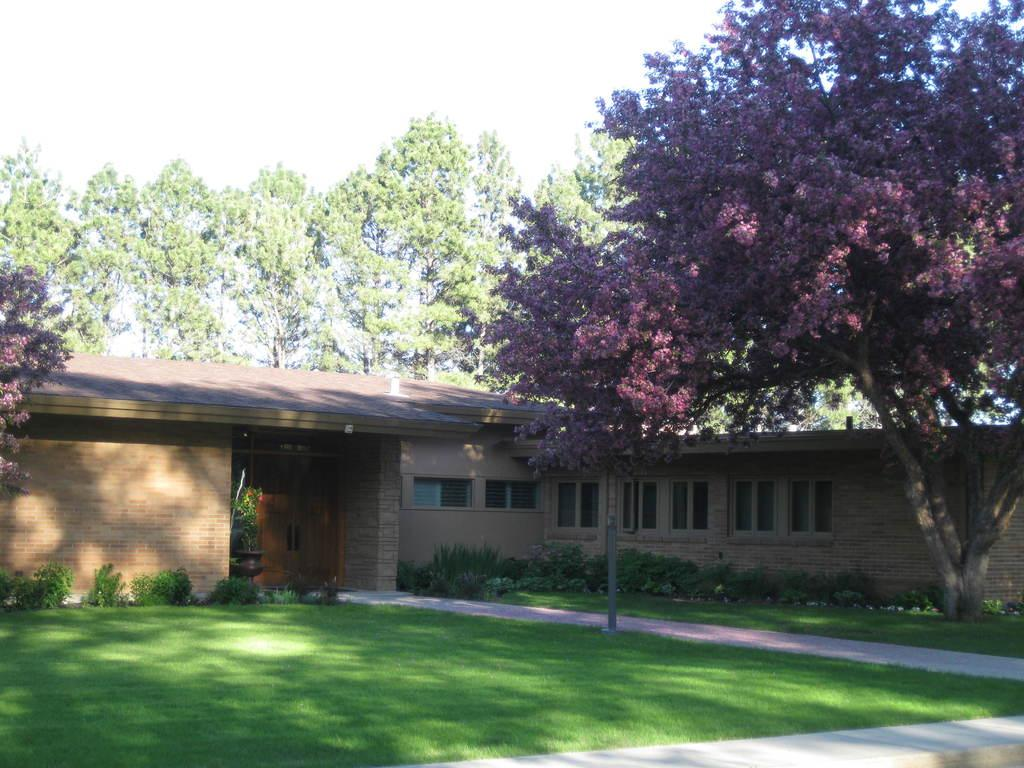What type of structure is visible in the image? There is a house in the image. What is located in front of the house? There is a ground in front of the house. What can be found on the ground in the image? There are plants and trees on the ground. What is visible in the background of the image? There are trees and the sky in the background of the image. How many gallons of oil are stored in the house in the image? There is no mention of oil or any storage in the house in the image. 